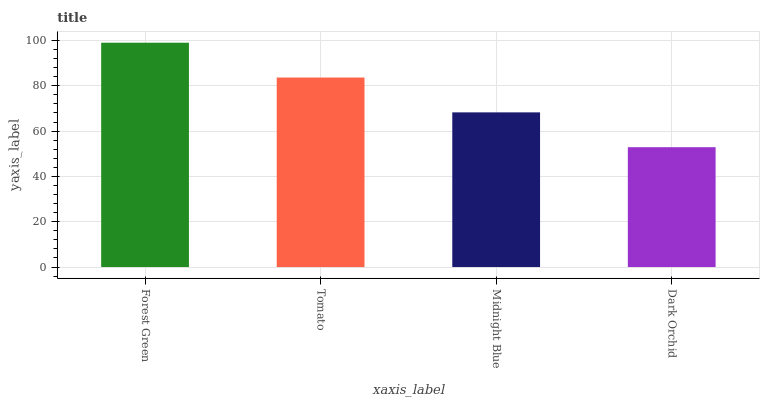Is Dark Orchid the minimum?
Answer yes or no. Yes. Is Forest Green the maximum?
Answer yes or no. Yes. Is Tomato the minimum?
Answer yes or no. No. Is Tomato the maximum?
Answer yes or no. No. Is Forest Green greater than Tomato?
Answer yes or no. Yes. Is Tomato less than Forest Green?
Answer yes or no. Yes. Is Tomato greater than Forest Green?
Answer yes or no. No. Is Forest Green less than Tomato?
Answer yes or no. No. Is Tomato the high median?
Answer yes or no. Yes. Is Midnight Blue the low median?
Answer yes or no. Yes. Is Forest Green the high median?
Answer yes or no. No. Is Tomato the low median?
Answer yes or no. No. 